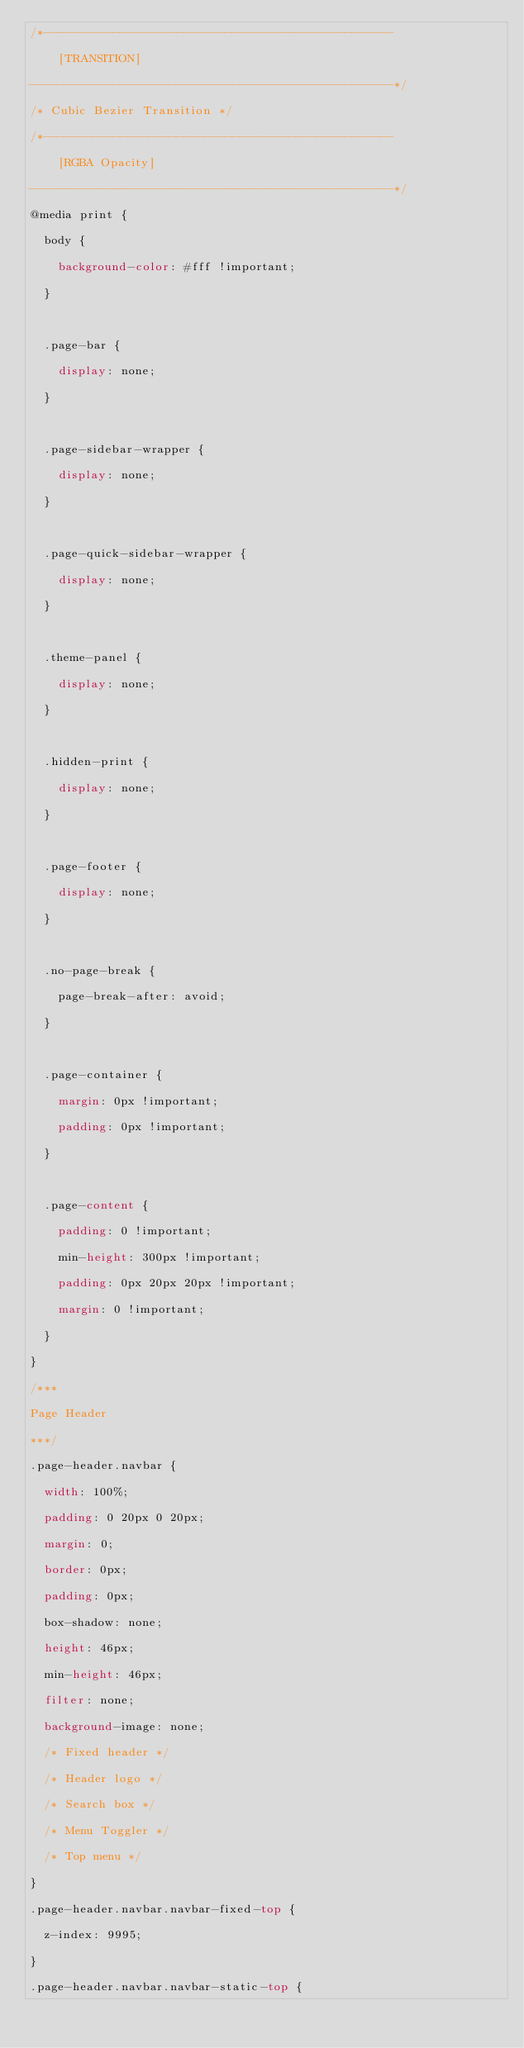<code> <loc_0><loc_0><loc_500><loc_500><_CSS_>/*--------------------------------------------------
    [TRANSITION]
----------------------------------------------------*/
/* Cubic Bezier Transition */
/*--------------------------------------------------
    [RGBA Opacity]
----------------------------------------------------*/
@media print {
  body {
    background-color: #fff !important;
  }

  .page-bar {
    display: none;
  }

  .page-sidebar-wrapper {
    display: none;
  }

  .page-quick-sidebar-wrapper {
    display: none;
  }

  .theme-panel {
    display: none;
  }

  .hidden-print {
    display: none;
  }

  .page-footer {
    display: none;
  }

  .no-page-break {
    page-break-after: avoid;
  }

  .page-container {
    margin: 0px !important;
    padding: 0px !important;
  }

  .page-content {
    padding: 0 !important;
    min-height: 300px !important;
    padding: 0px 20px 20px !important;
    margin: 0 !important;
  }
}
/***
Page Header
***/
.page-header.navbar {
  width: 100%;
  padding: 0 20px 0 20px;
  margin: 0;
  border: 0px;
  padding: 0px;
  box-shadow: none;
  height: 46px;
  min-height: 46px;
  filter: none;
  background-image: none;
  /* Fixed header */
  /* Header logo */
  /* Search box */
  /* Menu Toggler */
  /* Top menu */
}
.page-header.navbar.navbar-fixed-top {
  z-index: 9995;
}
.page-header.navbar.navbar-static-top {</code> 